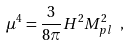<formula> <loc_0><loc_0><loc_500><loc_500>\mu ^ { 4 } = \frac { 3 } { 8 \pi } H ^ { 2 } M _ { p l } ^ { 2 } \ ,</formula> 